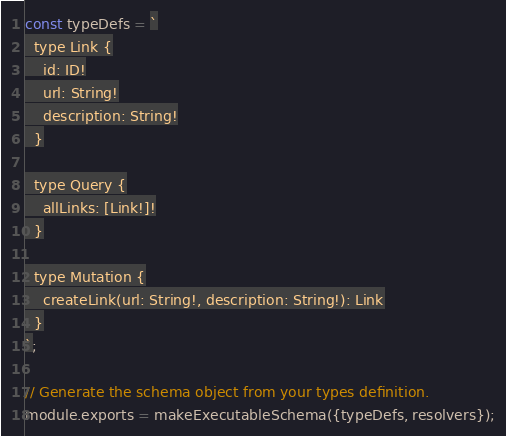<code> <loc_0><loc_0><loc_500><loc_500><_JavaScript_>const typeDefs = `
  type Link {
    id: ID!
    url: String!
    description: String!
  }

  type Query {
    allLinks: [Link!]!
  }

  type Mutation {
    createLink(url: String!, description: String!): Link
  }
`;

// Generate the schema object from your types definition.
module.exports = makeExecutableSchema({typeDefs, resolvers});
</code> 